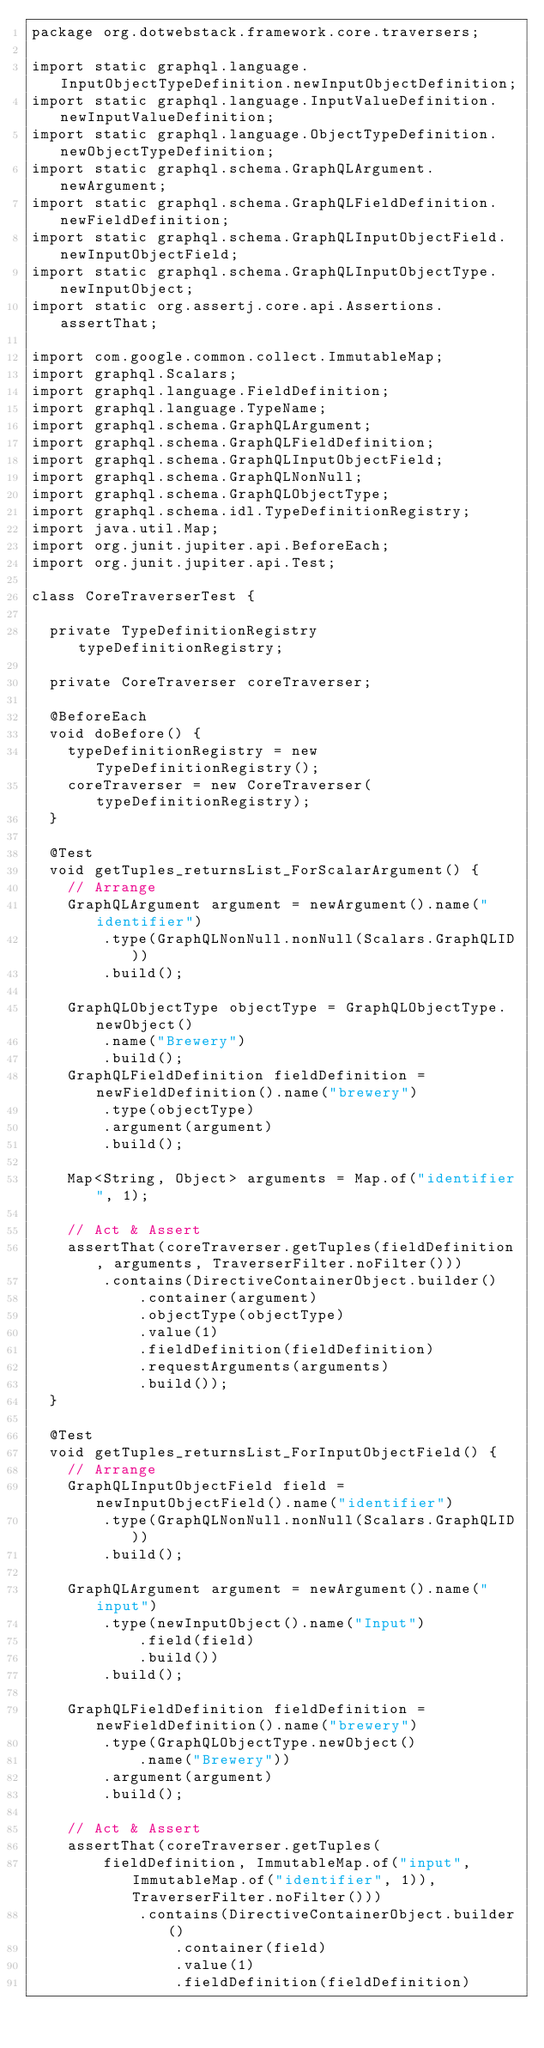Convert code to text. <code><loc_0><loc_0><loc_500><loc_500><_Java_>package org.dotwebstack.framework.core.traversers;

import static graphql.language.InputObjectTypeDefinition.newInputObjectDefinition;
import static graphql.language.InputValueDefinition.newInputValueDefinition;
import static graphql.language.ObjectTypeDefinition.newObjectTypeDefinition;
import static graphql.schema.GraphQLArgument.newArgument;
import static graphql.schema.GraphQLFieldDefinition.newFieldDefinition;
import static graphql.schema.GraphQLInputObjectField.newInputObjectField;
import static graphql.schema.GraphQLInputObjectType.newInputObject;
import static org.assertj.core.api.Assertions.assertThat;

import com.google.common.collect.ImmutableMap;
import graphql.Scalars;
import graphql.language.FieldDefinition;
import graphql.language.TypeName;
import graphql.schema.GraphQLArgument;
import graphql.schema.GraphQLFieldDefinition;
import graphql.schema.GraphQLInputObjectField;
import graphql.schema.GraphQLNonNull;
import graphql.schema.GraphQLObjectType;
import graphql.schema.idl.TypeDefinitionRegistry;
import java.util.Map;
import org.junit.jupiter.api.BeforeEach;
import org.junit.jupiter.api.Test;

class CoreTraverserTest {

  private TypeDefinitionRegistry typeDefinitionRegistry;

  private CoreTraverser coreTraverser;

  @BeforeEach
  void doBefore() {
    typeDefinitionRegistry = new TypeDefinitionRegistry();
    coreTraverser = new CoreTraverser(typeDefinitionRegistry);
  }

  @Test
  void getTuples_returnsList_ForScalarArgument() {
    // Arrange
    GraphQLArgument argument = newArgument().name("identifier")
        .type(GraphQLNonNull.nonNull(Scalars.GraphQLID))
        .build();

    GraphQLObjectType objectType = GraphQLObjectType.newObject()
        .name("Brewery")
        .build();
    GraphQLFieldDefinition fieldDefinition = newFieldDefinition().name("brewery")
        .type(objectType)
        .argument(argument)
        .build();

    Map<String, Object> arguments = Map.of("identifier", 1);

    // Act & Assert
    assertThat(coreTraverser.getTuples(fieldDefinition, arguments, TraverserFilter.noFilter()))
        .contains(DirectiveContainerObject.builder()
            .container(argument)
            .objectType(objectType)
            .value(1)
            .fieldDefinition(fieldDefinition)
            .requestArguments(arguments)
            .build());
  }

  @Test
  void getTuples_returnsList_ForInputObjectField() {
    // Arrange
    GraphQLInputObjectField field = newInputObjectField().name("identifier")
        .type(GraphQLNonNull.nonNull(Scalars.GraphQLID))
        .build();

    GraphQLArgument argument = newArgument().name("input")
        .type(newInputObject().name("Input")
            .field(field)
            .build())
        .build();

    GraphQLFieldDefinition fieldDefinition = newFieldDefinition().name("brewery")
        .type(GraphQLObjectType.newObject()
            .name("Brewery"))
        .argument(argument)
        .build();

    // Act & Assert
    assertThat(coreTraverser.getTuples(
        fieldDefinition, ImmutableMap.of("input", ImmutableMap.of("identifier", 1)), TraverserFilter.noFilter()))
            .contains(DirectiveContainerObject.builder()
                .container(field)
                .value(1)
                .fieldDefinition(fieldDefinition)</code> 